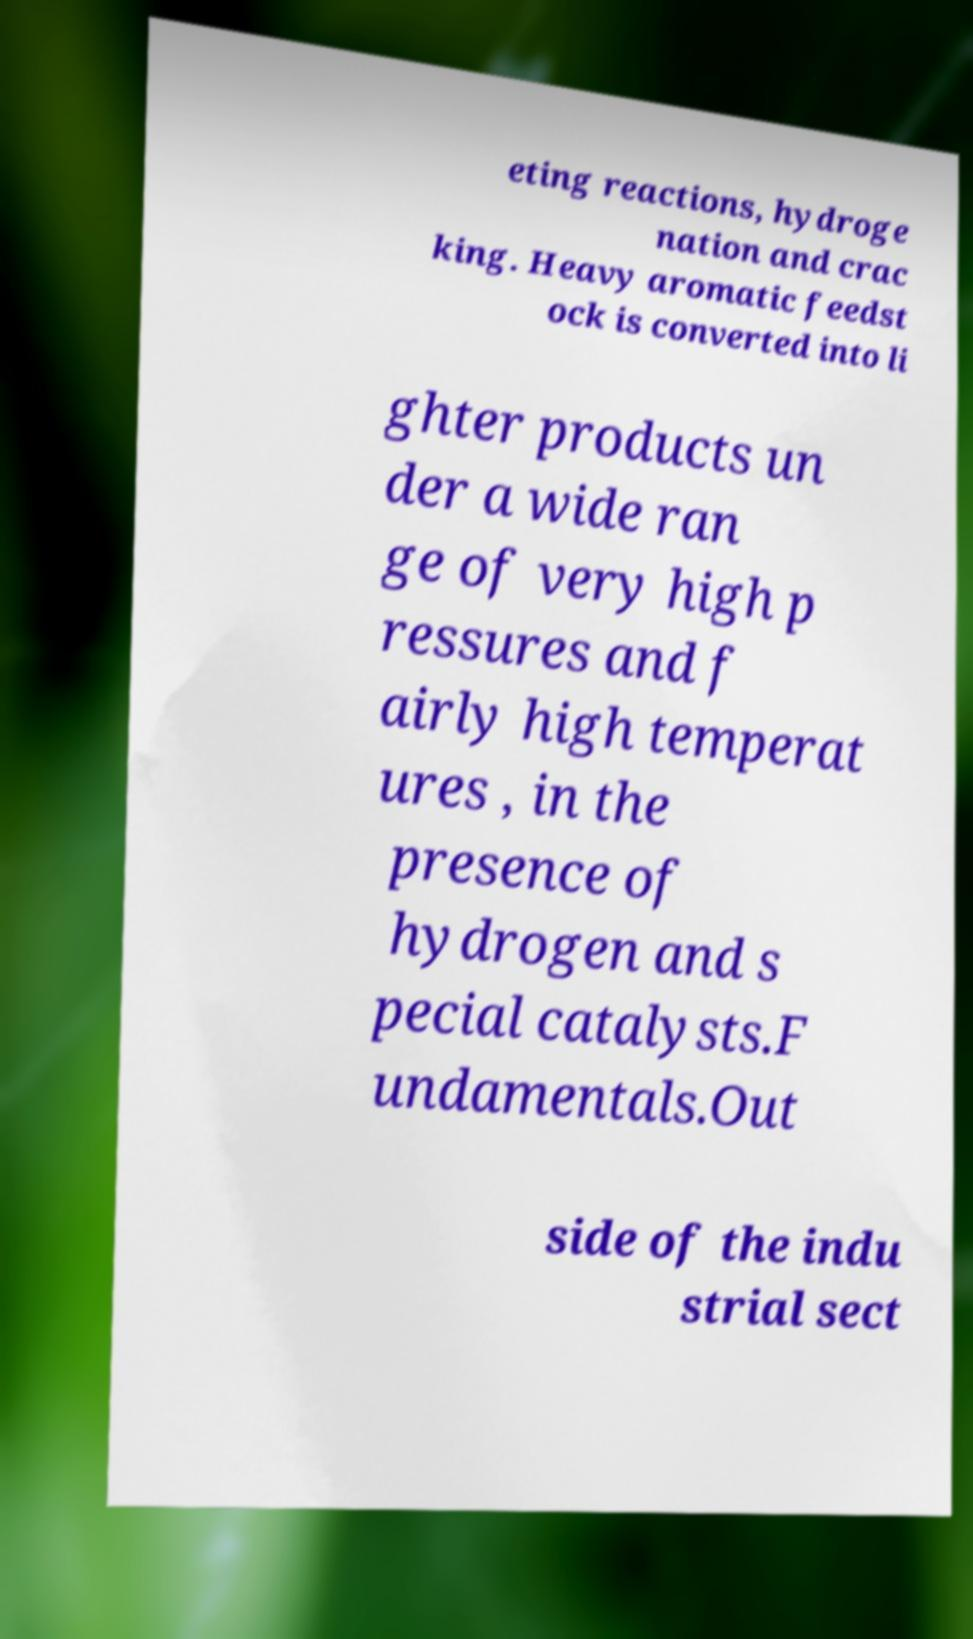For documentation purposes, I need the text within this image transcribed. Could you provide that? eting reactions, hydroge nation and crac king. Heavy aromatic feedst ock is converted into li ghter products un der a wide ran ge of very high p ressures and f airly high temperat ures , in the presence of hydrogen and s pecial catalysts.F undamentals.Out side of the indu strial sect 